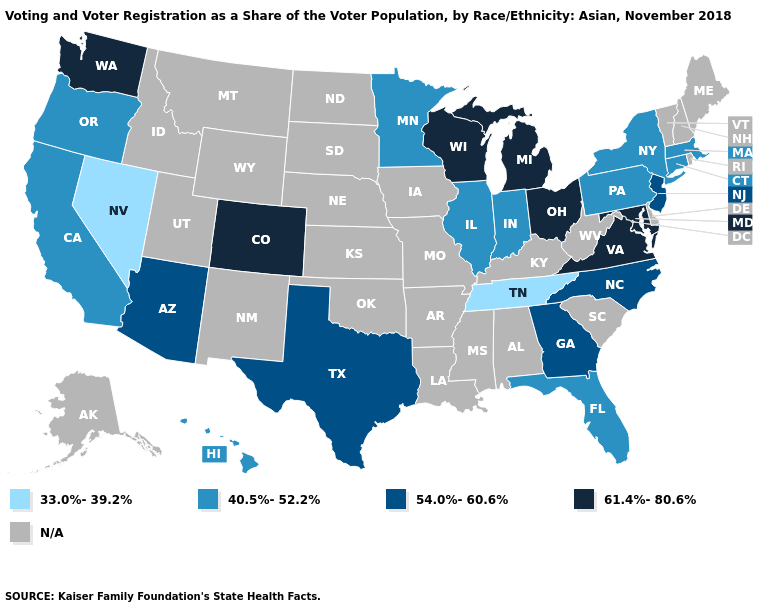What is the value of Montana?
Be succinct. N/A. Name the states that have a value in the range 40.5%-52.2%?
Answer briefly. California, Connecticut, Florida, Hawaii, Illinois, Indiana, Massachusetts, Minnesota, New York, Oregon, Pennsylvania. Name the states that have a value in the range 54.0%-60.6%?
Write a very short answer. Arizona, Georgia, New Jersey, North Carolina, Texas. What is the lowest value in the USA?
Be succinct. 33.0%-39.2%. What is the value of Utah?
Give a very brief answer. N/A. Among the states that border Georgia , does Tennessee have the lowest value?
Answer briefly. Yes. Does the map have missing data?
Short answer required. Yes. What is the highest value in the South ?
Short answer required. 61.4%-80.6%. Name the states that have a value in the range 33.0%-39.2%?
Keep it brief. Nevada, Tennessee. What is the lowest value in the MidWest?
Be succinct. 40.5%-52.2%. Does North Carolina have the highest value in the South?
Concise answer only. No. Does the first symbol in the legend represent the smallest category?
Short answer required. Yes. Among the states that border New York , does Connecticut have the highest value?
Keep it brief. No. Among the states that border Alabama , does Georgia have the highest value?
Write a very short answer. Yes. 